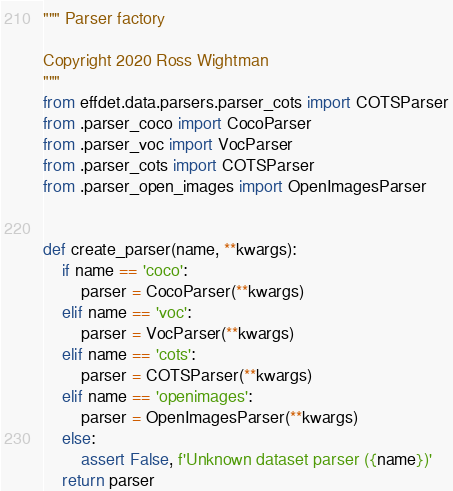Convert code to text. <code><loc_0><loc_0><loc_500><loc_500><_Python_>""" Parser factory

Copyright 2020 Ross Wightman
"""
from effdet.data.parsers.parser_cots import COTSParser
from .parser_coco import CocoParser
from .parser_voc import VocParser
from .parser_cots import COTSParser
from .parser_open_images import OpenImagesParser


def create_parser(name, **kwargs):
    if name == 'coco':
        parser = CocoParser(**kwargs)
    elif name == 'voc':
        parser = VocParser(**kwargs)
    elif name == 'cots':
        parser = COTSParser(**kwargs)
    elif name == 'openimages':
        parser = OpenImagesParser(**kwargs)
    else:
        assert False, f'Unknown dataset parser ({name})'
    return parser
</code> 